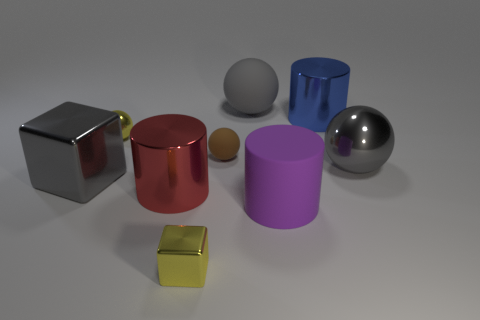How many gray balls must be subtracted to get 1 gray balls? 1 Subtract all big cubes. Subtract all tiny rubber objects. How many objects are left? 7 Add 7 tiny yellow metallic cubes. How many tiny yellow metallic cubes are left? 8 Add 9 big purple metallic blocks. How many big purple metallic blocks exist? 9 Add 1 matte cylinders. How many objects exist? 10 Subtract all yellow cubes. How many cubes are left? 1 Subtract all large metal spheres. How many spheres are left? 3 Subtract 0 cyan cylinders. How many objects are left? 9 Subtract all balls. How many objects are left? 5 Subtract 4 spheres. How many spheres are left? 0 